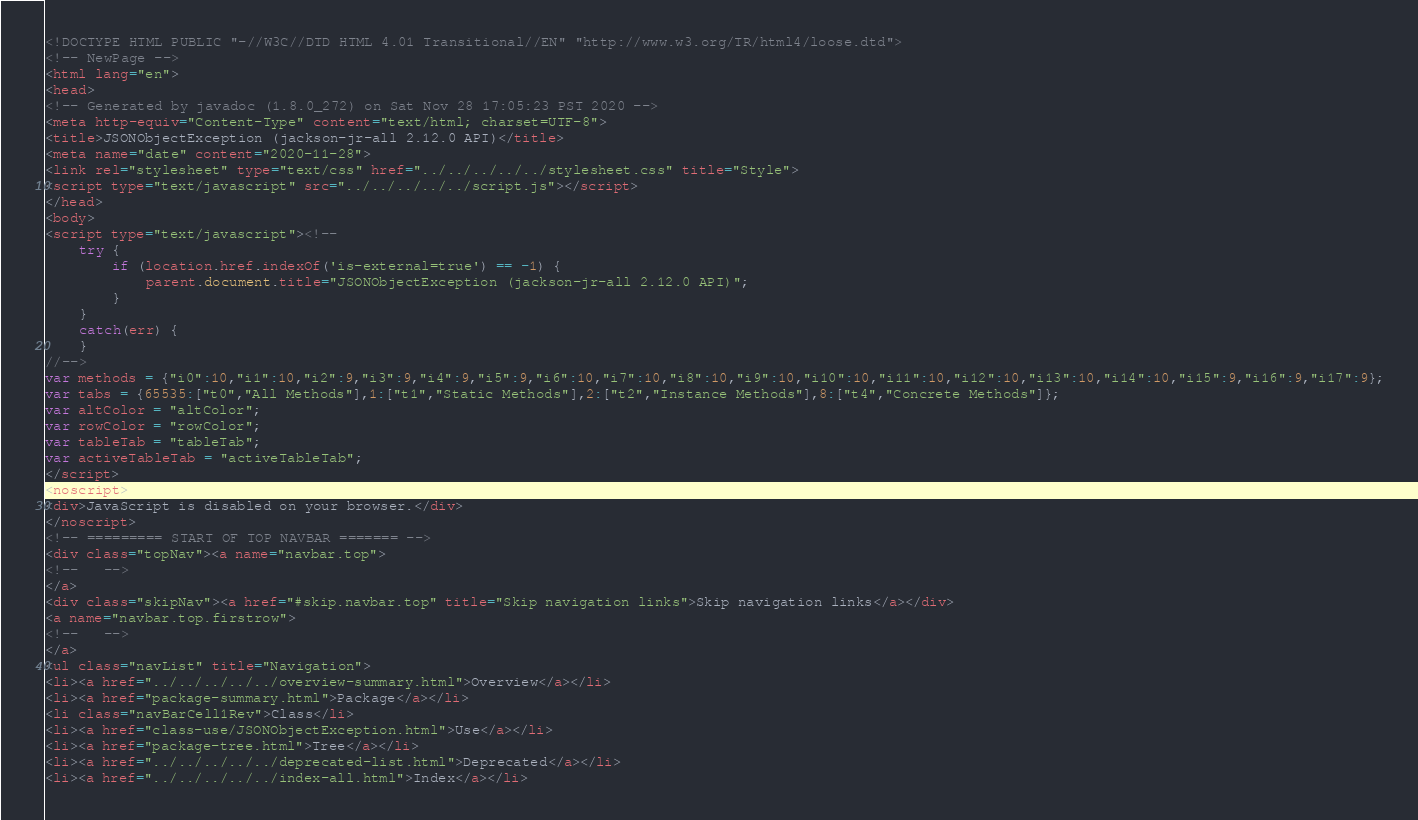<code> <loc_0><loc_0><loc_500><loc_500><_HTML_><!DOCTYPE HTML PUBLIC "-//W3C//DTD HTML 4.01 Transitional//EN" "http://www.w3.org/TR/html4/loose.dtd">
<!-- NewPage -->
<html lang="en">
<head>
<!-- Generated by javadoc (1.8.0_272) on Sat Nov 28 17:05:23 PST 2020 -->
<meta http-equiv="Content-Type" content="text/html; charset=UTF-8">
<title>JSONObjectException (jackson-jr-all 2.12.0 API)</title>
<meta name="date" content="2020-11-28">
<link rel="stylesheet" type="text/css" href="../../../../../stylesheet.css" title="Style">
<script type="text/javascript" src="../../../../../script.js"></script>
</head>
<body>
<script type="text/javascript"><!--
    try {
        if (location.href.indexOf('is-external=true') == -1) {
            parent.document.title="JSONObjectException (jackson-jr-all 2.12.0 API)";
        }
    }
    catch(err) {
    }
//-->
var methods = {"i0":10,"i1":10,"i2":9,"i3":9,"i4":9,"i5":9,"i6":10,"i7":10,"i8":10,"i9":10,"i10":10,"i11":10,"i12":10,"i13":10,"i14":10,"i15":9,"i16":9,"i17":9};
var tabs = {65535:["t0","All Methods"],1:["t1","Static Methods"],2:["t2","Instance Methods"],8:["t4","Concrete Methods"]};
var altColor = "altColor";
var rowColor = "rowColor";
var tableTab = "tableTab";
var activeTableTab = "activeTableTab";
</script>
<noscript>
<div>JavaScript is disabled on your browser.</div>
</noscript>
<!-- ========= START OF TOP NAVBAR ======= -->
<div class="topNav"><a name="navbar.top">
<!--   -->
</a>
<div class="skipNav"><a href="#skip.navbar.top" title="Skip navigation links">Skip navigation links</a></div>
<a name="navbar.top.firstrow">
<!--   -->
</a>
<ul class="navList" title="Navigation">
<li><a href="../../../../../overview-summary.html">Overview</a></li>
<li><a href="package-summary.html">Package</a></li>
<li class="navBarCell1Rev">Class</li>
<li><a href="class-use/JSONObjectException.html">Use</a></li>
<li><a href="package-tree.html">Tree</a></li>
<li><a href="../../../../../deprecated-list.html">Deprecated</a></li>
<li><a href="../../../../../index-all.html">Index</a></li></code> 